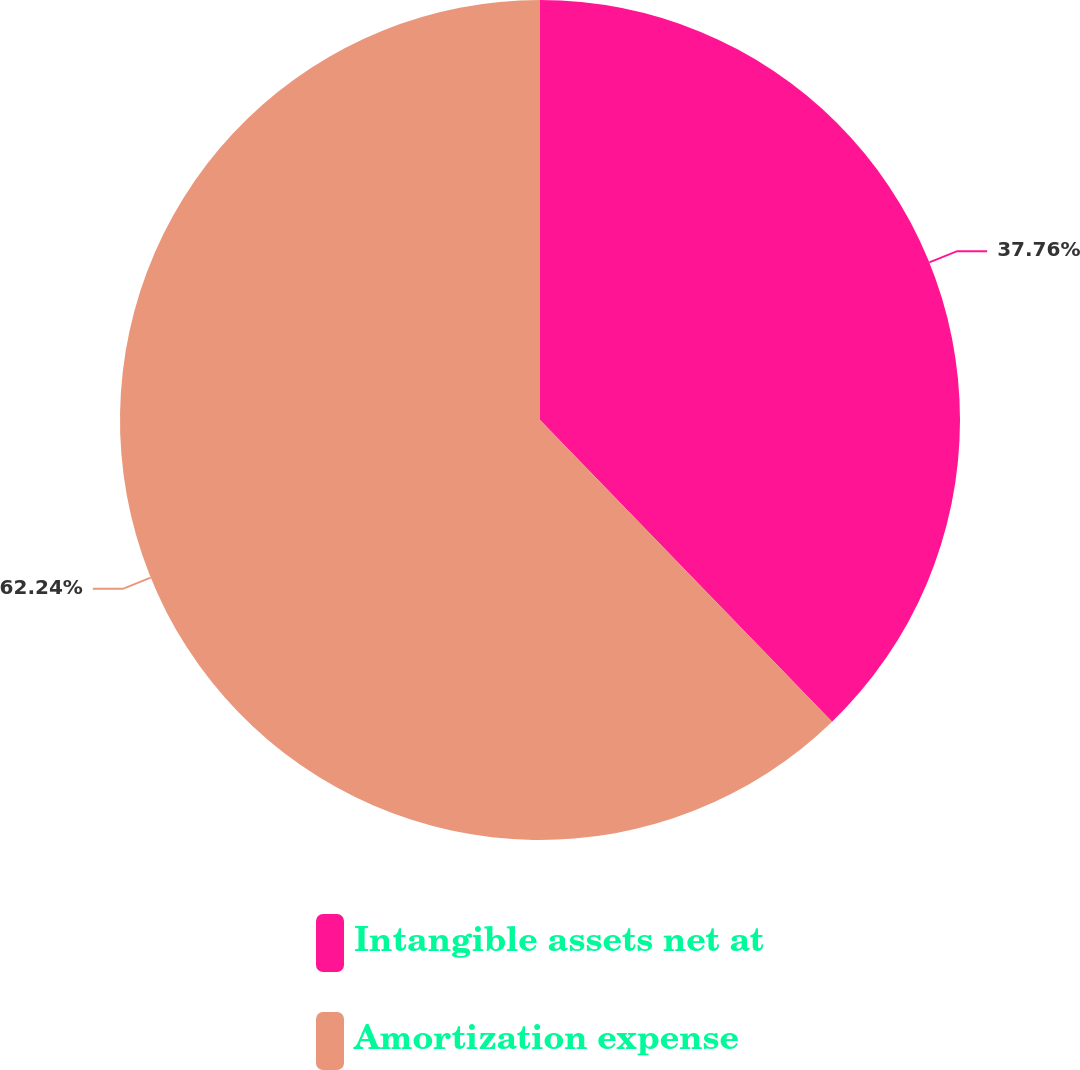Convert chart to OTSL. <chart><loc_0><loc_0><loc_500><loc_500><pie_chart><fcel>Intangible assets net at<fcel>Amortization expense<nl><fcel>37.76%<fcel>62.24%<nl></chart> 